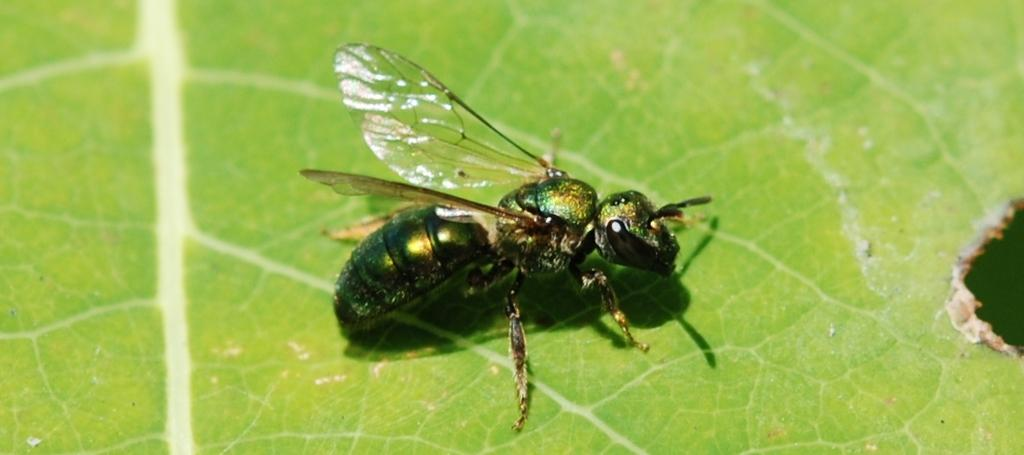What is present in the image? There is a fly in the image. Where is the fly located? The fly is on a green leaf. How many kittens are playing with a sense on a plate in the image? There are no kittens, sense, or plate present in the image; it only features a fly on a green leaf. 